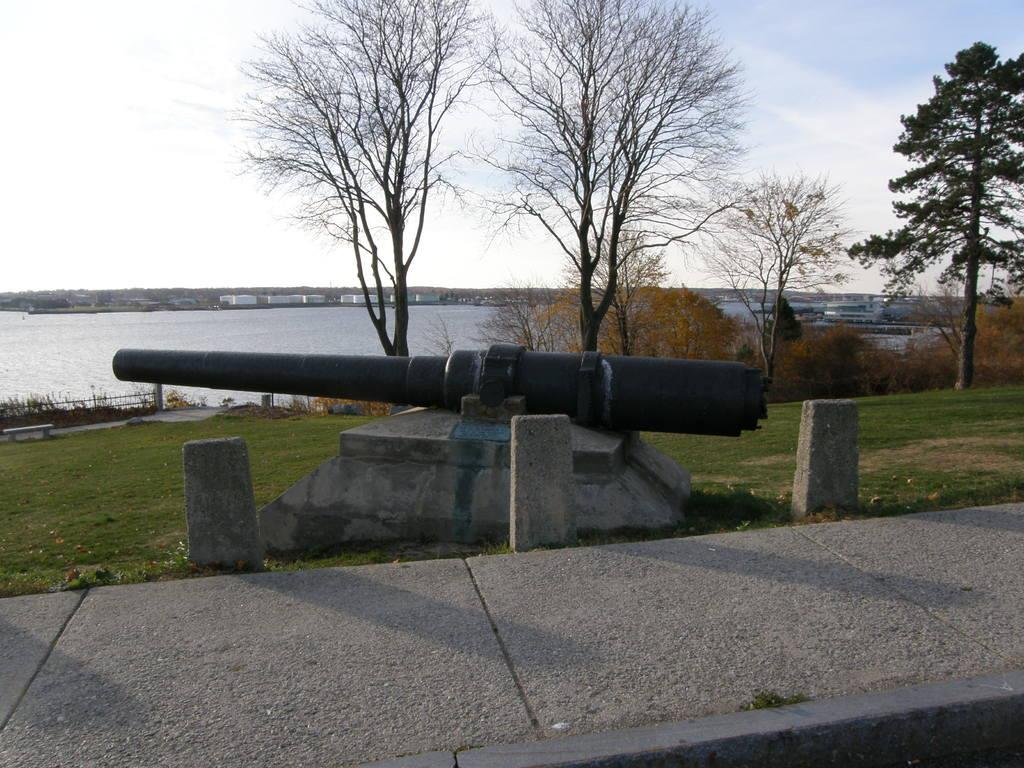What object in the image can be used for defense or attack? There is a weapon in the image that can be used for defense or attack. How is the weapon positioned in the image? The weapon is kept on the ground in the image. What type of natural environment can be seen in the image? There are trees and a river visible in the image. How many friends are holding the nail in the image? There is no nail or friends present in the image. What time does the clock show in the image? There are no clocks present in the image. 